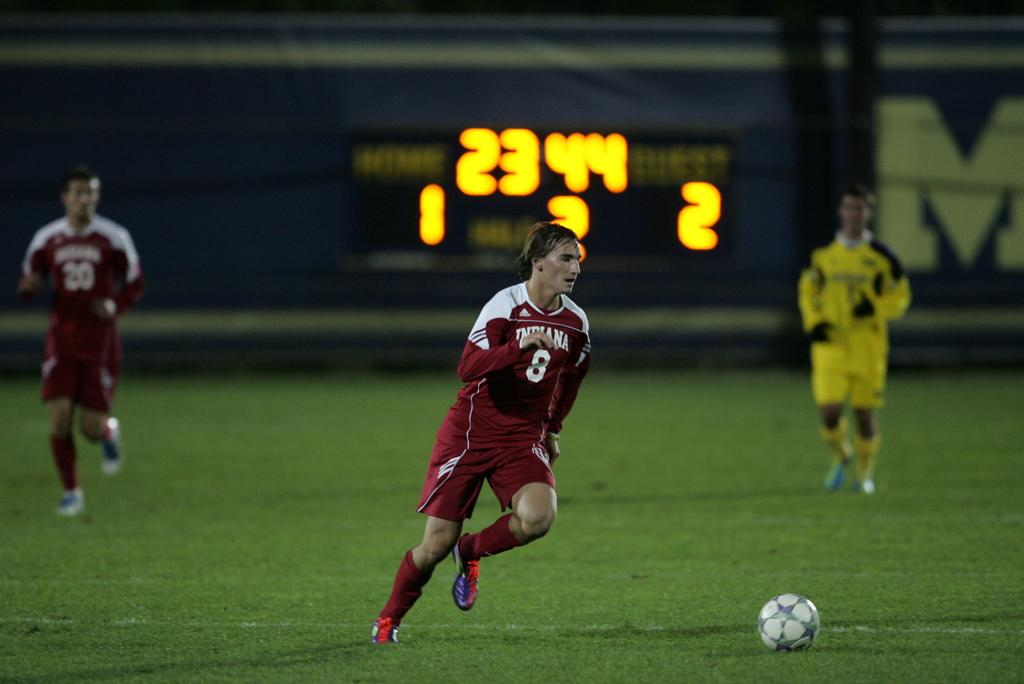What are the three people in the image doing? The three people in the image are playing football. What object is at the bottom of the image? There is a ball at the bottom of the image. What can be seen in the background of the image? There is a board in the background of the image. What is the tendency of the joke to affect the territory in the image? There is no joke or territory present in the image; it features three people playing football with a ball. 